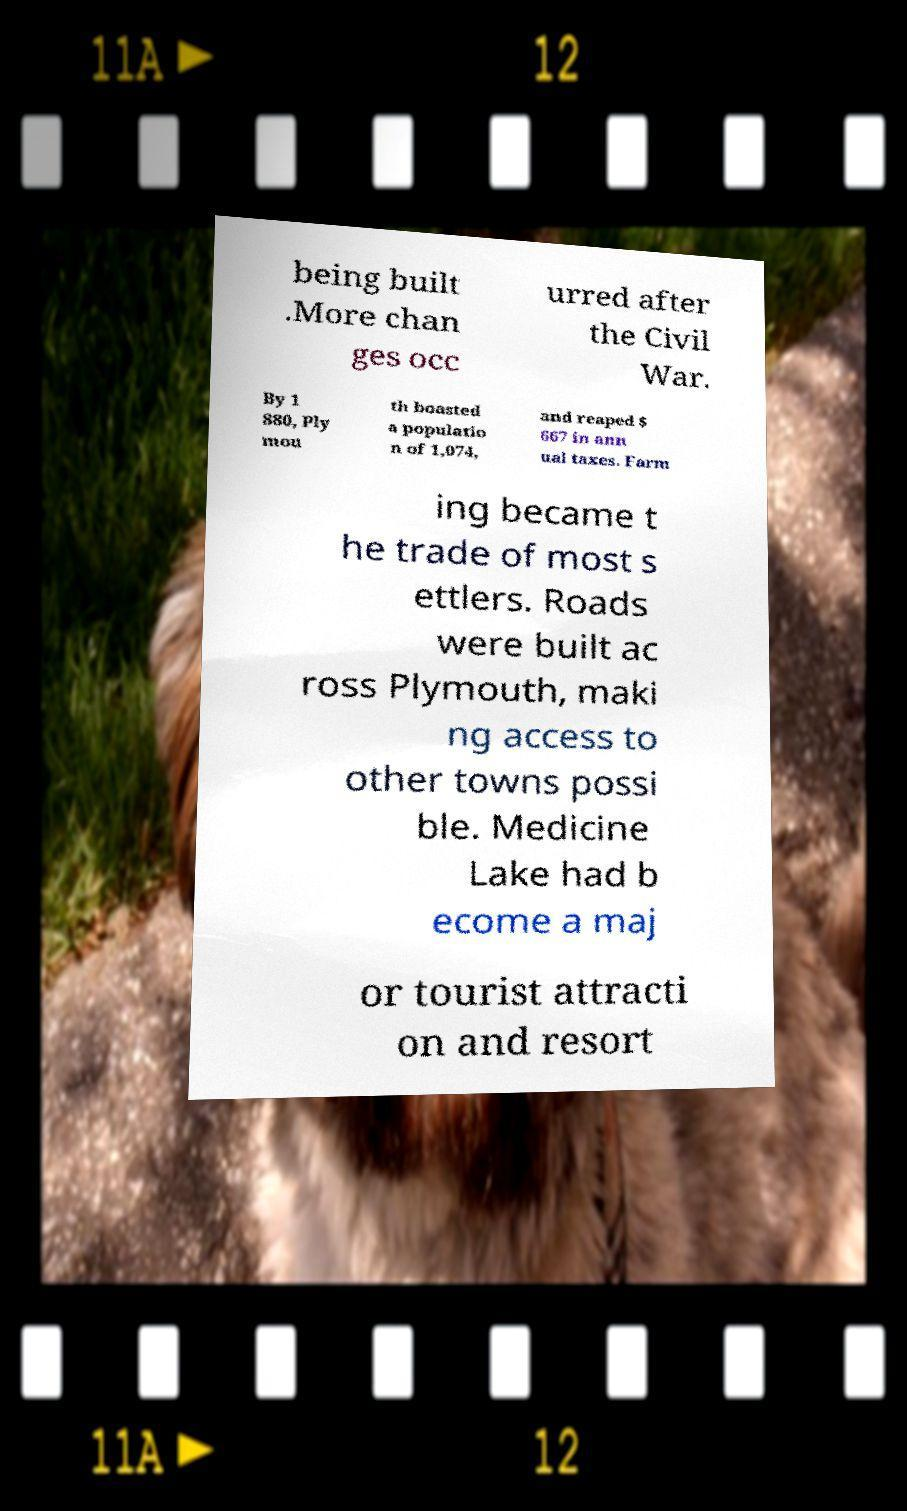Can you read and provide the text displayed in the image?This photo seems to have some interesting text. Can you extract and type it out for me? being built .More chan ges occ urred after the Civil War. By 1 880, Ply mou th boasted a populatio n of 1,074, and reaped $ 667 in ann ual taxes. Farm ing became t he trade of most s ettlers. Roads were built ac ross Plymouth, maki ng access to other towns possi ble. Medicine Lake had b ecome a maj or tourist attracti on and resort 